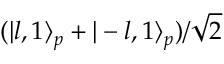Convert formula to latex. <formula><loc_0><loc_0><loc_500><loc_500>( | l , 1 \rangle _ { p } + | - l , 1 \rangle _ { p } ) / { \sqrt { 2 } }</formula> 